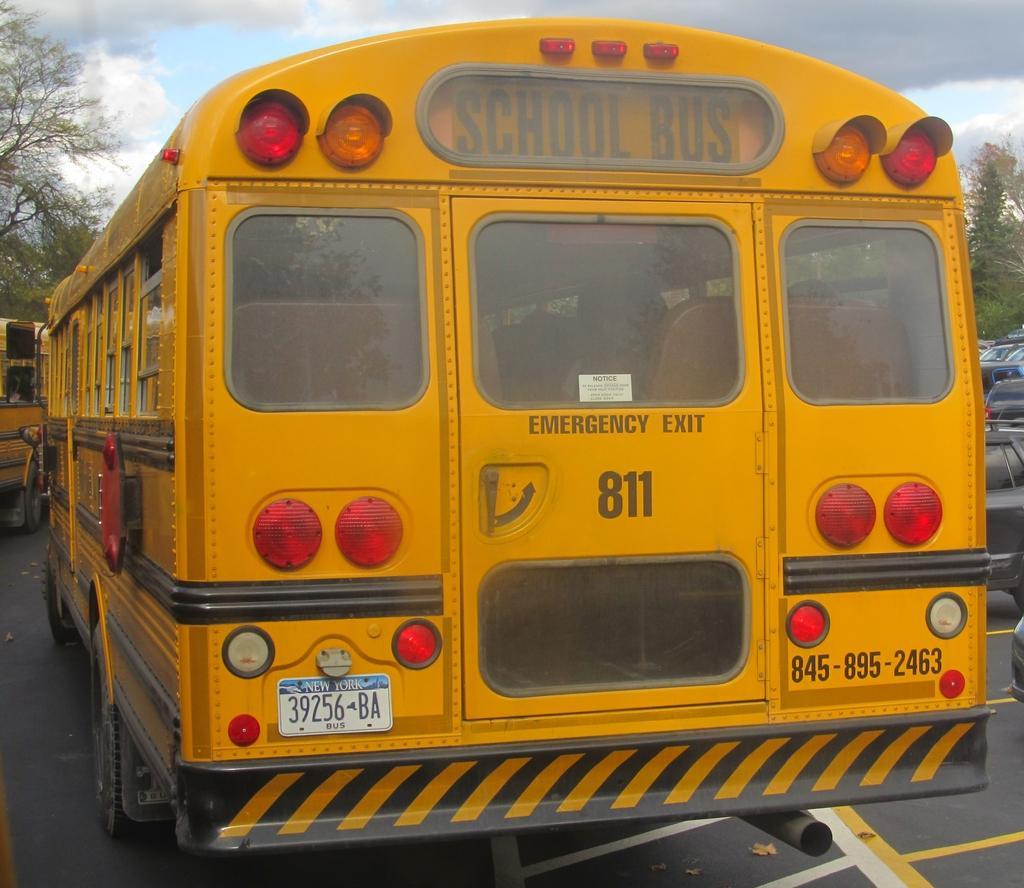How would you summarize this image in a sentence or two? Here we can see a bus on the road. In the background there are vehicles on the road,trees and clouds in the sky. 